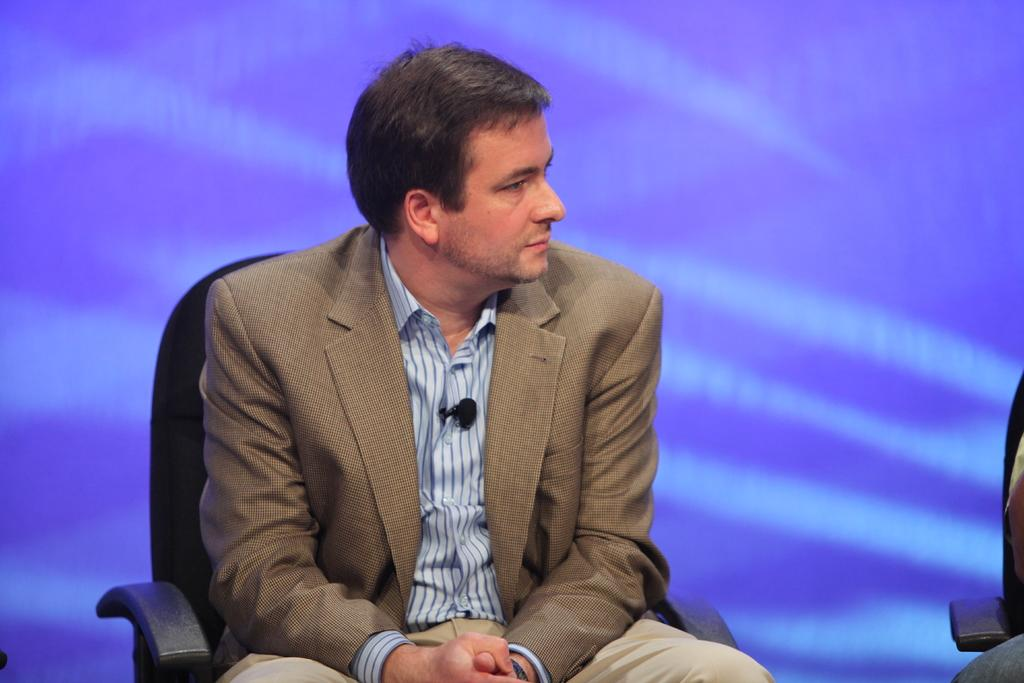Who is present in the image? There is a man in the image. What is the man wearing? The man is wearing a blazer. What is the man doing in the image? The man is sitting on a chair and looking at a person beside him. What can be seen in the background of the image? There is a wall in the background of the image. How many grapes can be seen on the man's plate in the image? There is no plate or grapes present in the image. Is there a horse visible in the image? No, there is no horse present in the image. 